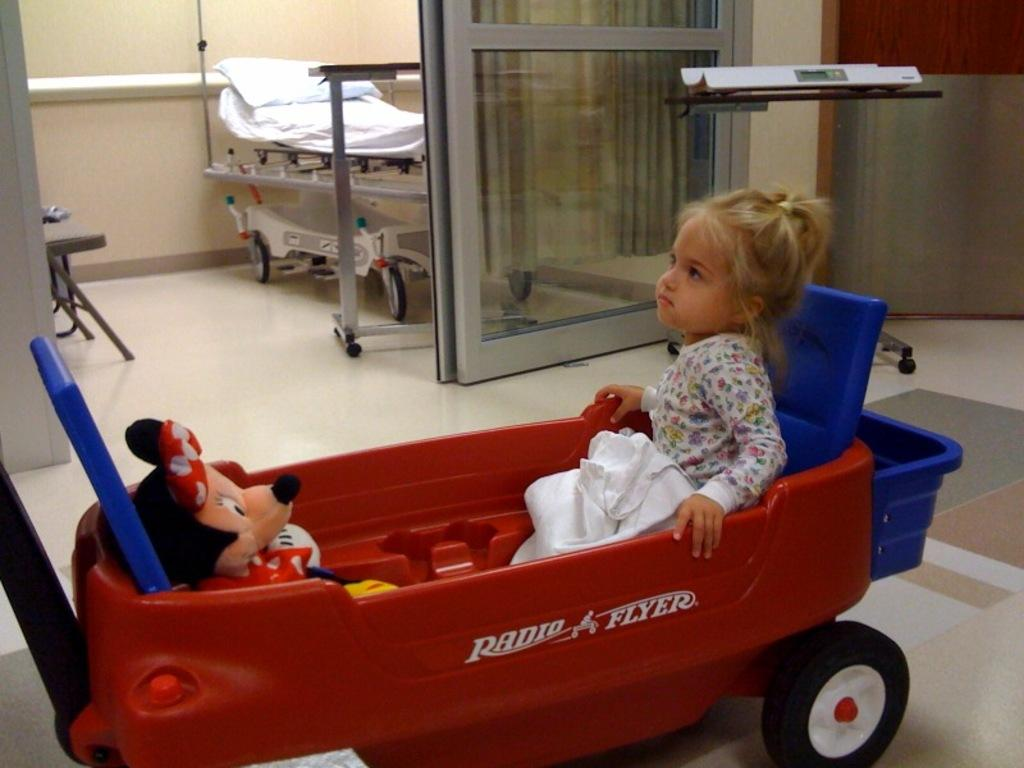Who is the main subject in the foreground of the image? There is a girl in the foreground of the image. What is the girl sitting on? The girl is sitting on a wheel cart. What can be seen in the background of the image? There is a glass door, a bed, and chairs in the background of the image. What is visible on the floor in the image? The floor is visible in the image. How many apples are on the bed in the image? There are no apples present in the image; the bed is empty. Can you tell me how many chickens are visible through the glass door? There are no chickens visible through the glass door in the image. 